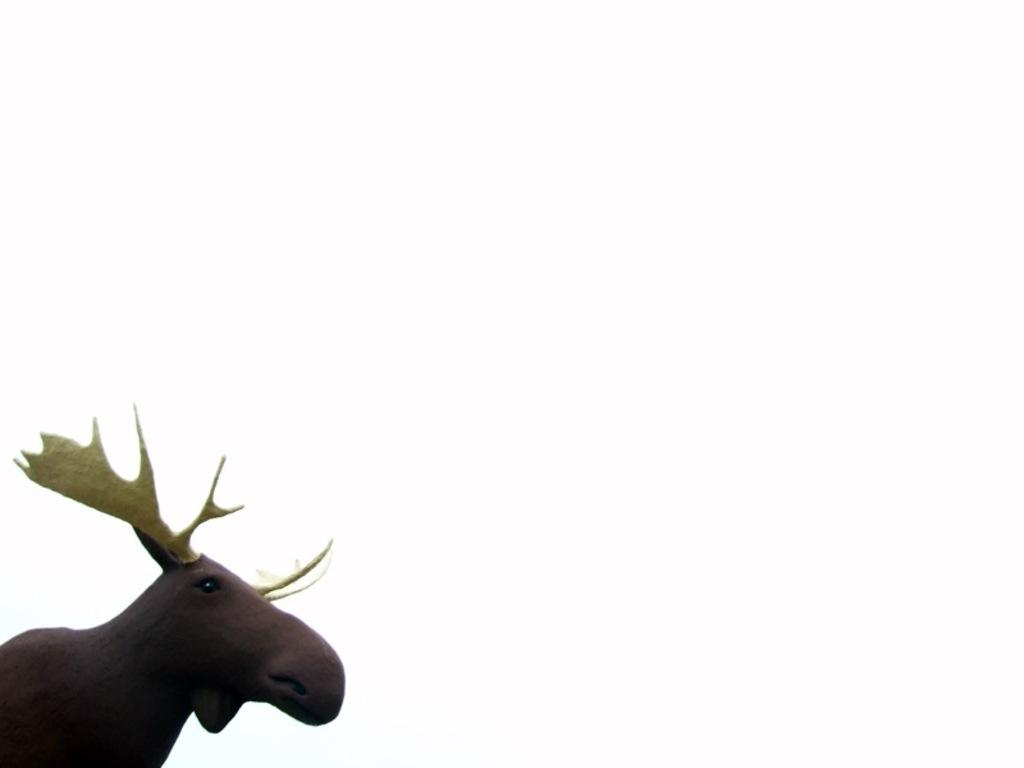What is the main subject of the picture? The main subject of the picture is a sculpture of a stag. What color is the sculpture? The sculpture is brown in color. What color are the stag's horns? The stag's horns are yellow in color. Is there a throne made of gold in the picture? No, there is no throne present in the image. 